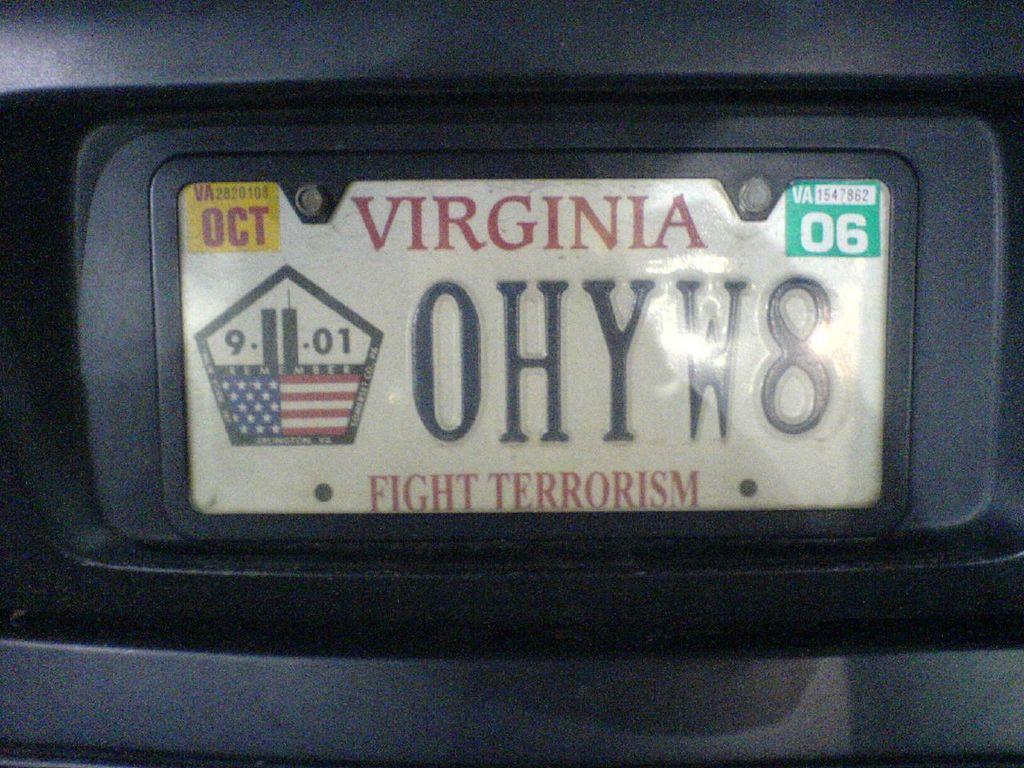How would you summarize this image in a sentence or two? In this image, there is a white color board, on that board there is VIRGINIA is printed in red color and OHYW8 FIGHT Terrorism is printed. 